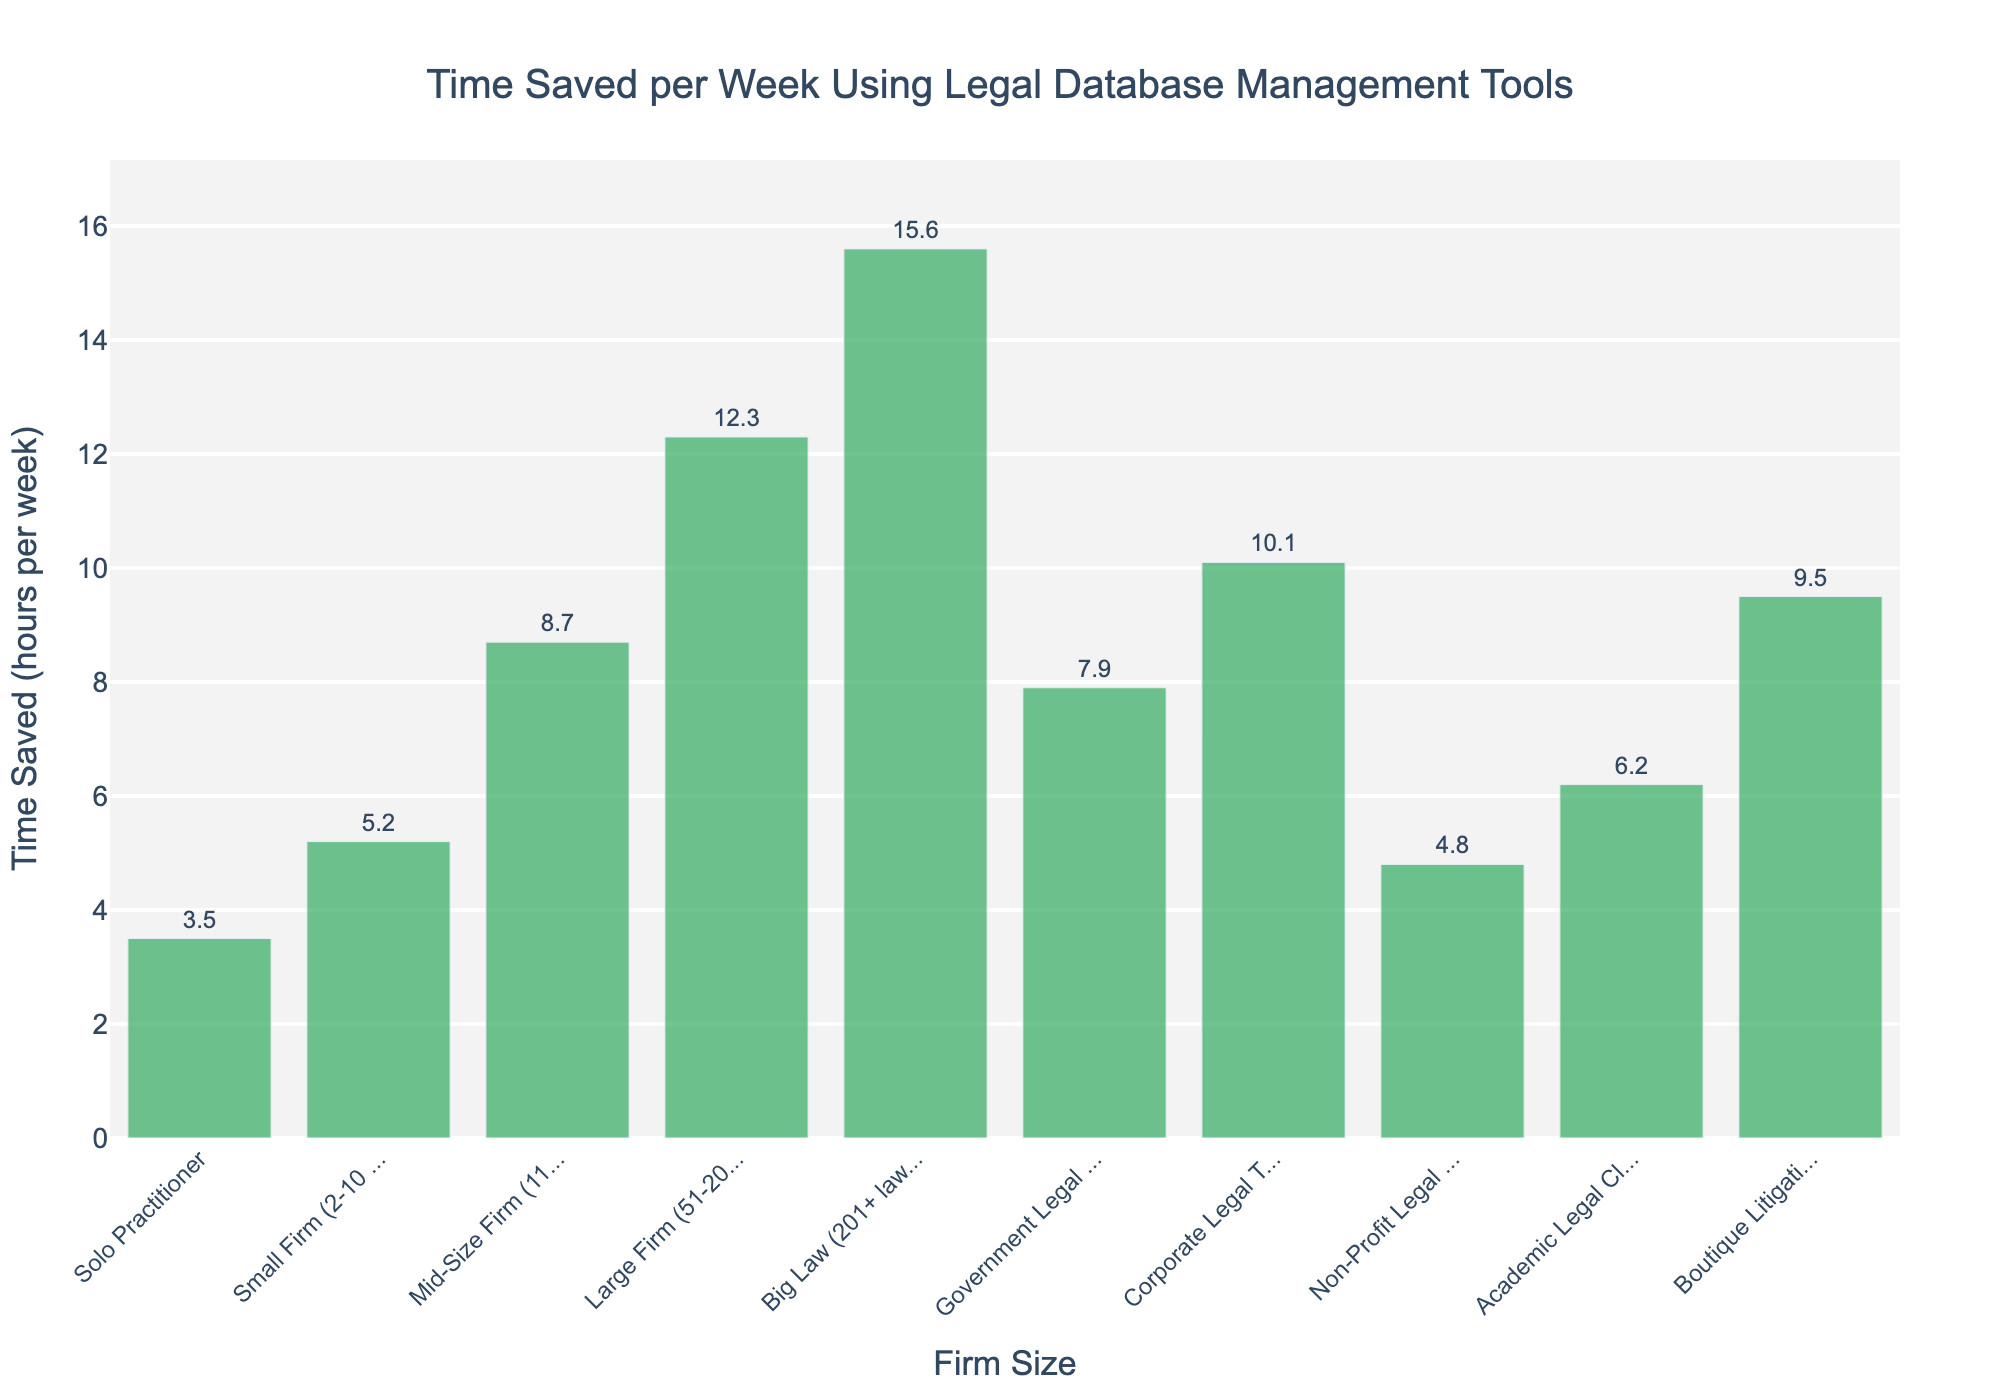Which firm size saves the most time per week? By observing the height of the bars and labels, Big Law (201+ lawyers) saves the most time per week with 15.6 hours
Answer: Big Law (201+ lawyers) Which firm size saves the least time per week? By observing the height of the bars and labels, Solo Practitioners save the least time per week with 3.5 hours
Answer: Solo Practitioner What is the difference in time saved between Big Law and Solo Practitioners? Big Law saves 15.6 hours, and Solo Practitioners save 3.5 hours. The difference is 15.6 - 3.5 = 12.1 hours
Answer: 12.1 hours How much time does a Corporate Legal Team save compared to a Government Legal Department? A Corporate Legal Team saves 10.1 hours, while a Government Legal Department saves 7.9 hours. The difference is 10.1 - 7.9 = 2.2 hours
Answer: 2.2 hours What is the average time saved across all firm sizes? Add all the time saved values: 3.5 + 5.2 + 8.7 + 12.3 + 15.6 + 7.9 + 10.1 + 4.8 + 6.2 + 9.5 = 83.8 hours. Divide by the number of firm sizes (10): 83.8 / 10 = 8.38 hours
Answer: 8.38 hours Is the time saved by Small Firms (2-10 lawyers) greater than that by Non-Profit Legal Aid? Small Firms save 5.2 hours, while Non-Profit Legal Aid saves 4.8 hours. Since 5.2 > 4.8, Small Firms save more time
Answer: Yes What is the median time saved across all firm sizes? List times saved in ascending order: 3.5, 4.8, 5.2, 6.2, 7.9, 8.7, 9.5, 10.1, 12.3, 15.6. Median is the average of the 5th and 6th values: (7.9 + 8.7) / 2 = 8.3 hours
Answer: 8.3 hours Which firm size category saves almost double the time of an Academic Legal Clinic? An Academic Legal Clinic saves 6.2 hours. Double is approximately 12.4 hours. A Large Firm (51-200 lawyers) saves 12.3 hours, which is closest to double 6.2
Answer: Large Firm (51-200 lawyers) What is the combined time saved by Large Firms and Big Law? Large Firms save 12.3 hours, and Big Law saves 15.6 hours. Combined, they save 12.3 + 15.6 = 27.9 hours
Answer: 27.9 hours 